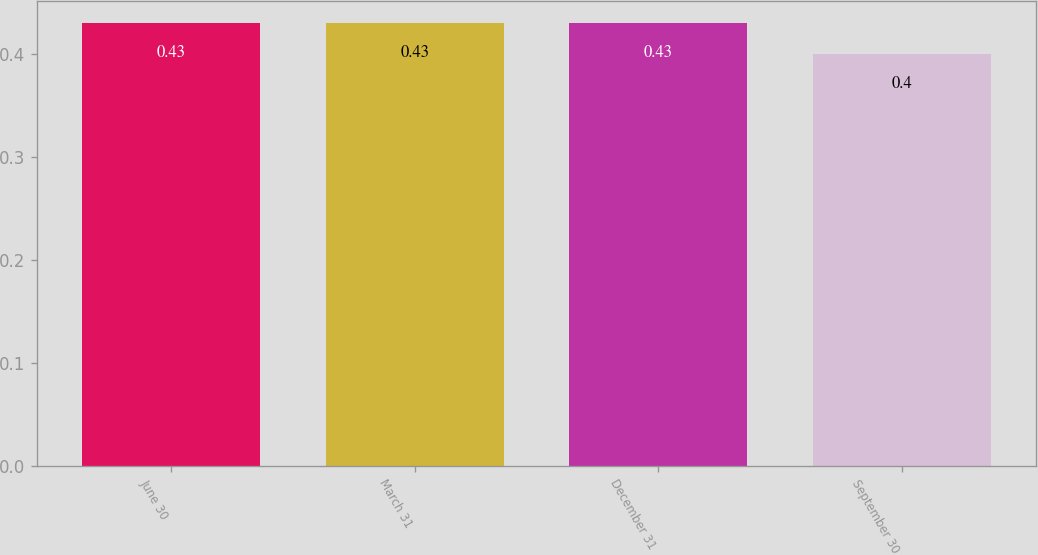<chart> <loc_0><loc_0><loc_500><loc_500><bar_chart><fcel>June 30<fcel>March 31<fcel>December 31<fcel>September 30<nl><fcel>0.43<fcel>0.43<fcel>0.43<fcel>0.4<nl></chart> 